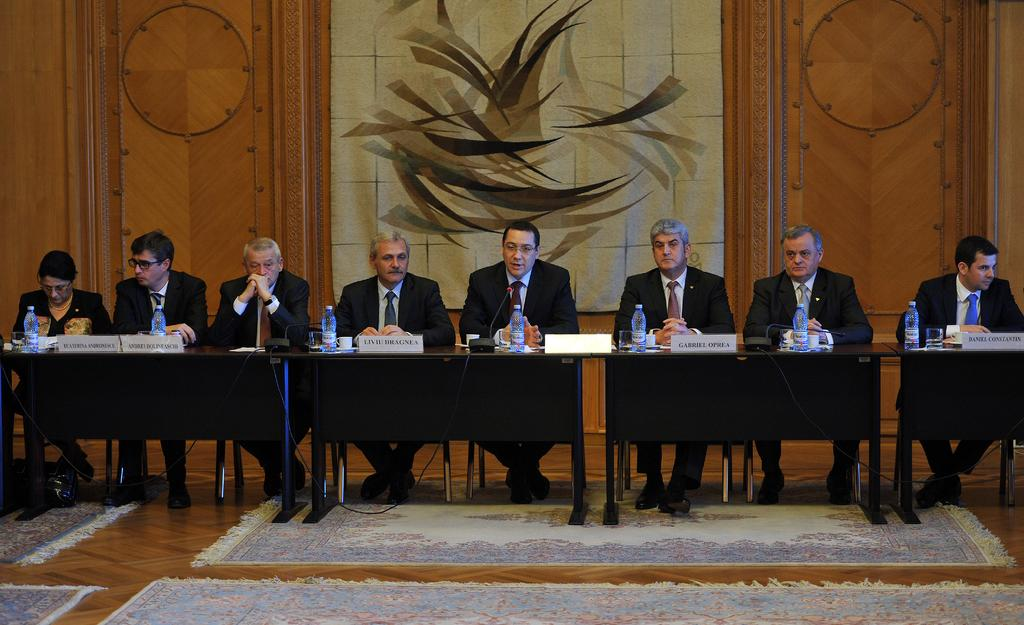How many people are sitting in the image? There are eight people sitting on chairs in the image. What objects can be seen on the table? There is a bottle and a cup on the table. Are the people in the image wearing masks? There is no mention of masks in the image, so we cannot determine if the people are wearing them. 